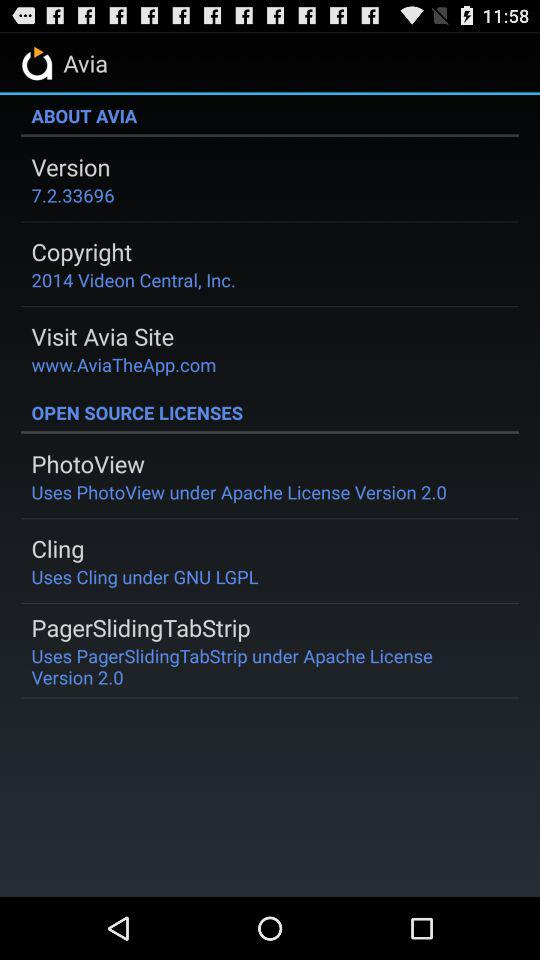What is the name of the application? The name of the application is "Avia". 